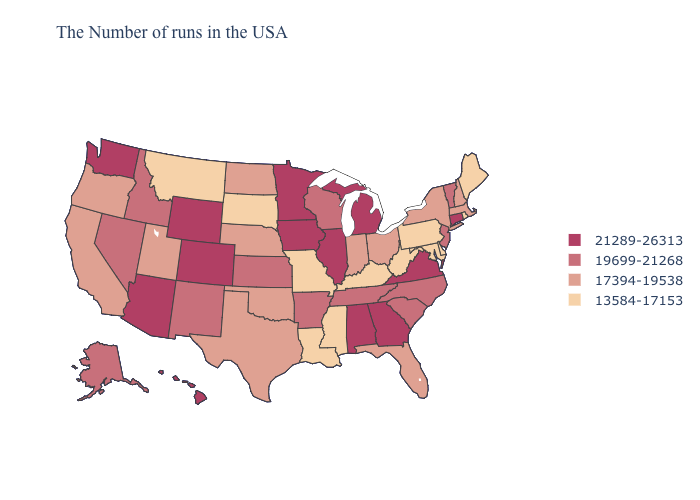Is the legend a continuous bar?
Give a very brief answer. No. Name the states that have a value in the range 17394-19538?
Quick response, please. Massachusetts, New Hampshire, New York, Ohio, Florida, Indiana, Nebraska, Oklahoma, Texas, North Dakota, Utah, California, Oregon. What is the value of Oregon?
Quick response, please. 17394-19538. What is the lowest value in states that border Arkansas?
Quick response, please. 13584-17153. What is the value of Washington?
Quick response, please. 21289-26313. Does Rhode Island have the lowest value in the Northeast?
Give a very brief answer. Yes. Name the states that have a value in the range 13584-17153?
Answer briefly. Maine, Rhode Island, Delaware, Maryland, Pennsylvania, West Virginia, Kentucky, Mississippi, Louisiana, Missouri, South Dakota, Montana. What is the highest value in the USA?
Quick response, please. 21289-26313. How many symbols are there in the legend?
Answer briefly. 4. What is the value of Alaska?
Be succinct. 19699-21268. Does Oregon have the highest value in the USA?
Quick response, please. No. What is the highest value in states that border Nevada?
Concise answer only. 21289-26313. Name the states that have a value in the range 17394-19538?
Be succinct. Massachusetts, New Hampshire, New York, Ohio, Florida, Indiana, Nebraska, Oklahoma, Texas, North Dakota, Utah, California, Oregon. What is the value of Rhode Island?
Short answer required. 13584-17153. 